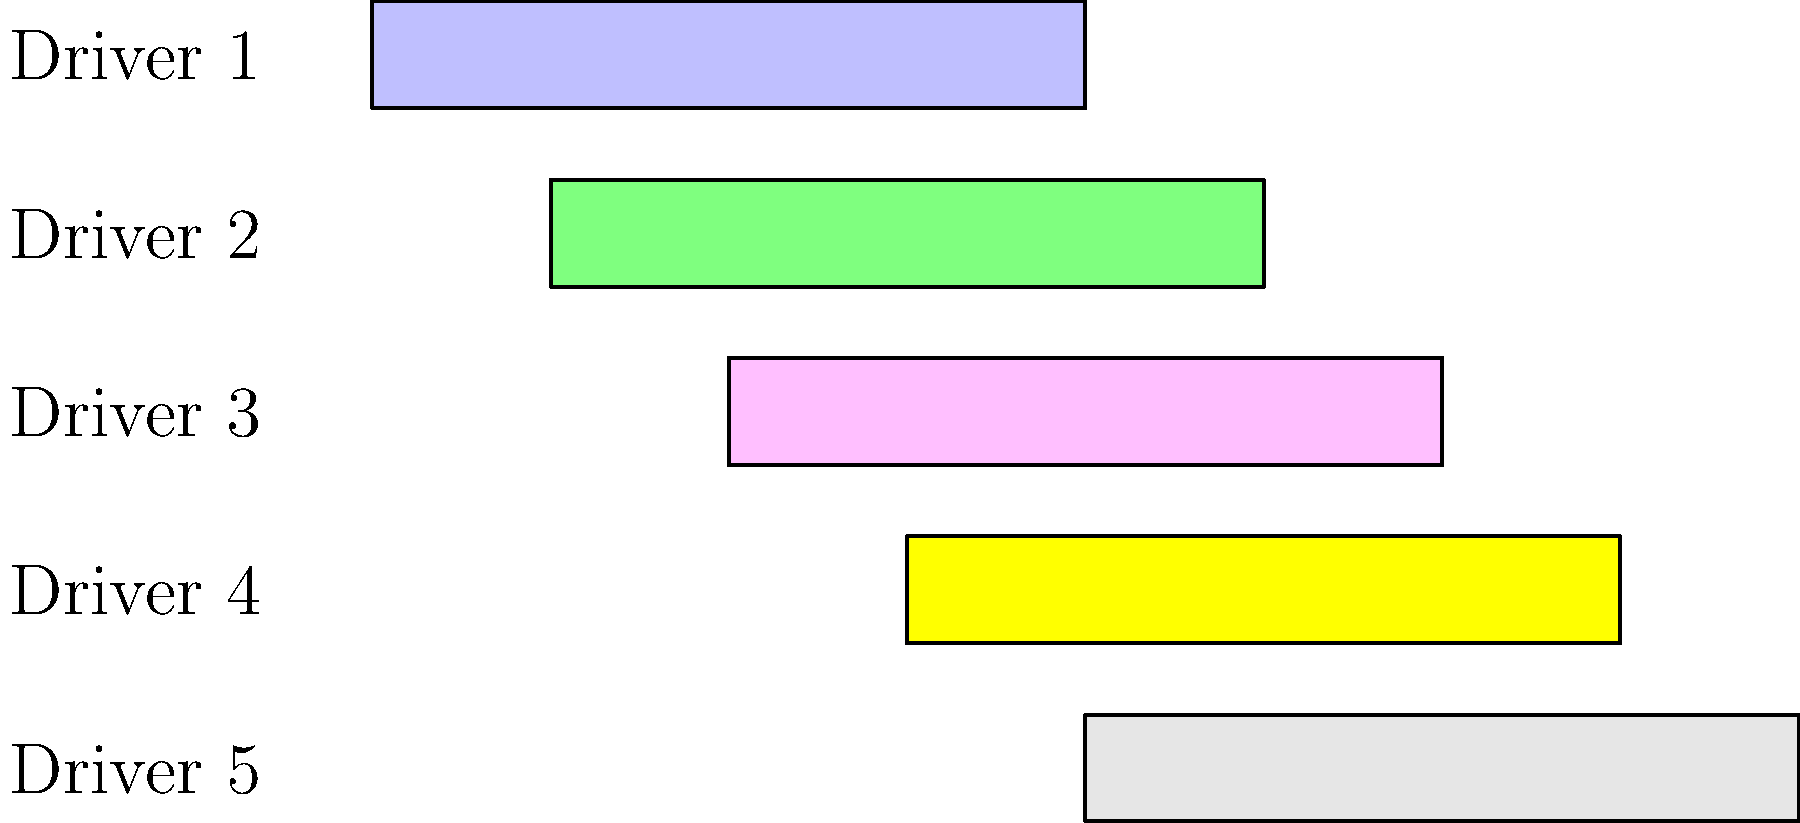Based on the Gantt chart showing driver shifts for coffee deliveries, what is the minimum number of drivers needed to ensure continuous delivery coverage for the entire 8-hour period? To determine the minimum number of drivers needed for continuous coverage, we need to analyze the Gantt chart step by step:

1. Examine the start and end times for each driver:
   Driver 1: 4-8 hours
   Driver 2: 3-7 hours
   Driver 3: 2-6 hours
   Driver 4: 1-5 hours
   Driver 5: 0-4 hours

2. Identify the coverage for each hour:
   Hour 0-1: Driver 5
   Hour 1-2: Drivers 4 and 5
   Hour 2-3: Drivers 3, 4, and 5
   Hour 3-4: Drivers 2, 3, 4, and 5
   Hour 4-5: Drivers 1, 2, 3, and 4
   Hour 5-6: Drivers 1, 2, and 3
   Hour 6-7: Drivers 1 and 2
   Hour 7-8: Driver 1

3. Determine the minimum number of drivers needed:
   We need at least one driver for each hour of the 8-hour period.
   Looking at the coverage, we can see that removing any single driver would leave at least one hour uncovered.

4. Conclusion:
   The minimum number of drivers needed is 5, as each driver covers a unique portion of the 8-hour period that isn't fully covered by the other drivers.
Answer: 5 drivers 